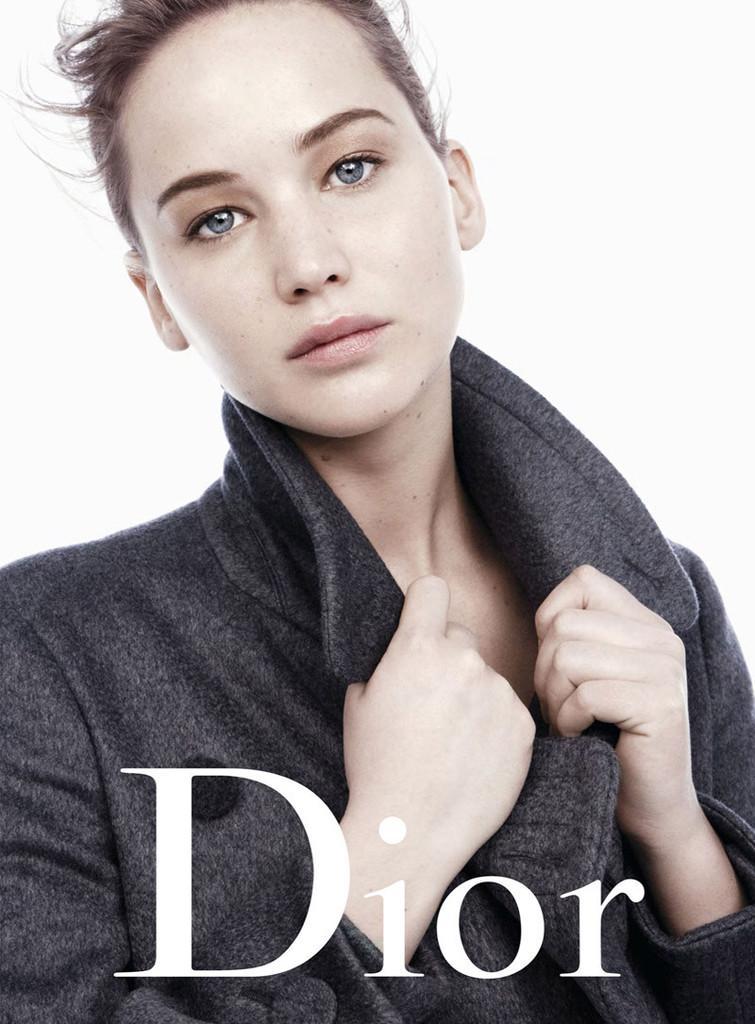Could you give a brief overview of what you see in this image? The picture is a magazine cover photo. In this picture there is a woman holding a jacket. At the bottom there is text. The background is white. 